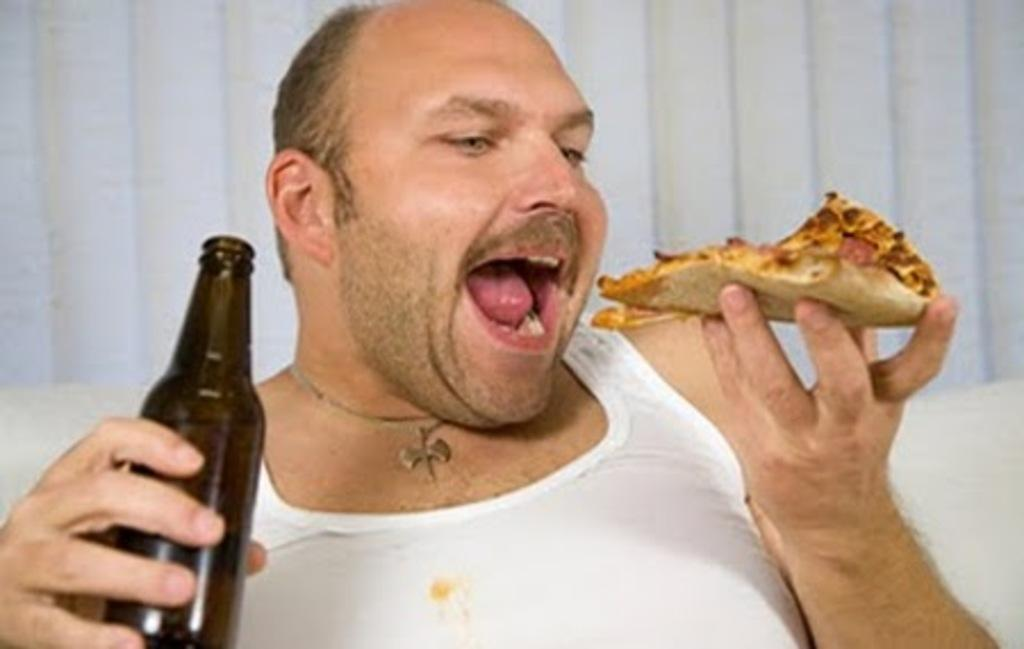What is the main subject of the image? There is a person in the image. What is the person holding in their right hand? The person is holding a bottle in their right hand. What is the person holding in their left hand? The person is holding a pizza in their left hand. What type of ticket is the person holding in the image? There is no ticket present in the image; the person is holding a bottle and a pizza. What invention is the person using to hold the pizza in the image? The person is not using any invention to hold the pizza; they are simply holding it in their left hand. 